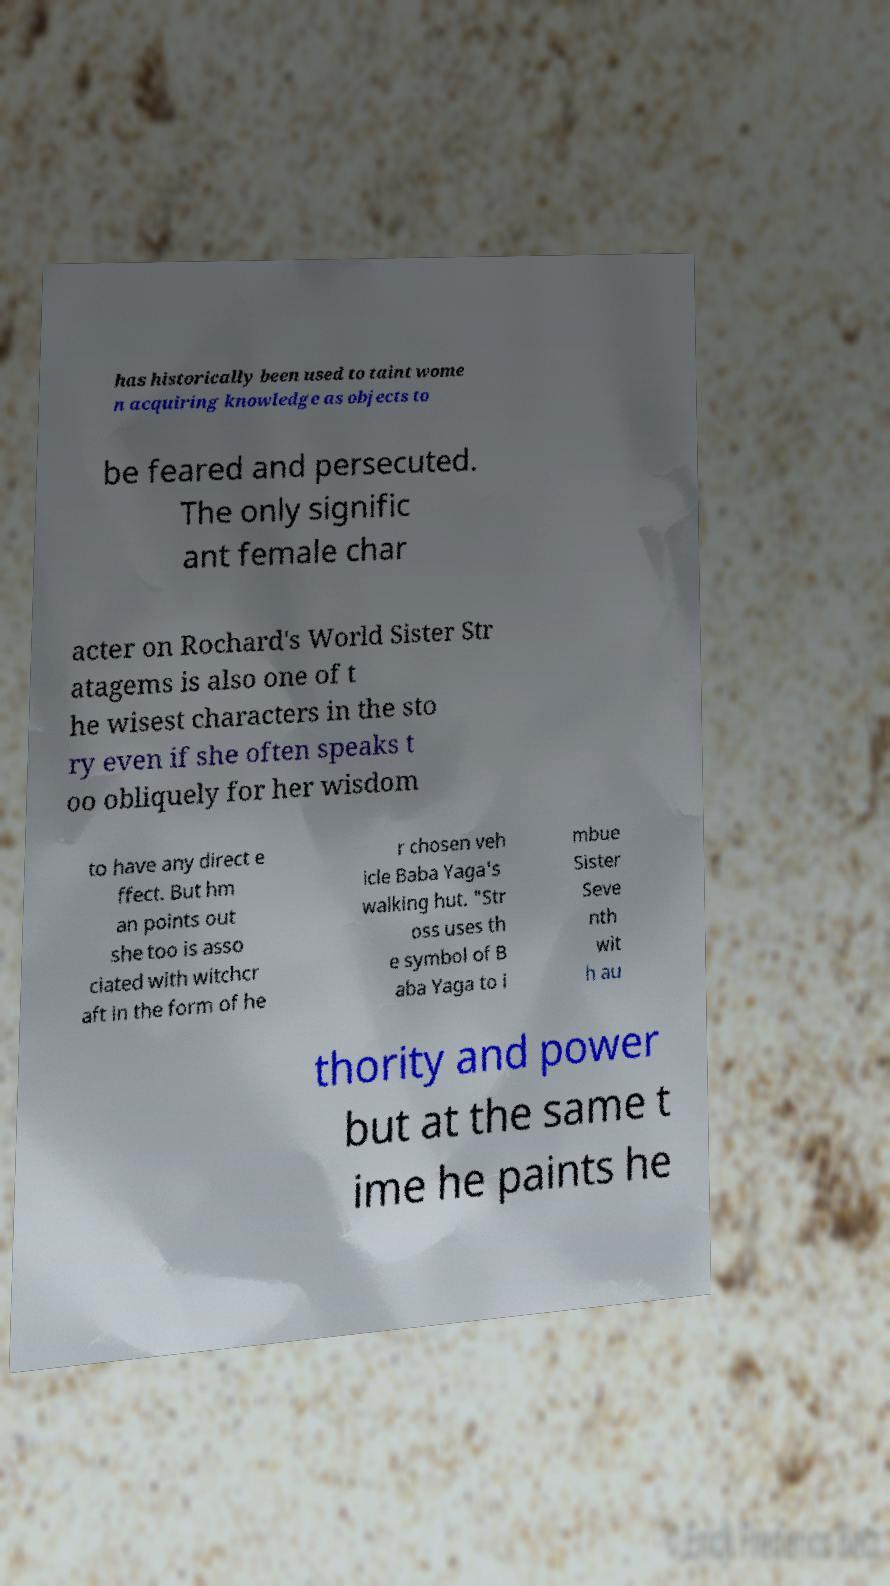Can you read and provide the text displayed in the image?This photo seems to have some interesting text. Can you extract and type it out for me? has historically been used to taint wome n acquiring knowledge as objects to be feared and persecuted. The only signific ant female char acter on Rochard's World Sister Str atagems is also one of t he wisest characters in the sto ry even if she often speaks t oo obliquely for her wisdom to have any direct e ffect. But hm an points out she too is asso ciated with witchcr aft in the form of he r chosen veh icle Baba Yaga's walking hut. "Str oss uses th e symbol of B aba Yaga to i mbue Sister Seve nth wit h au thority and power but at the same t ime he paints he 